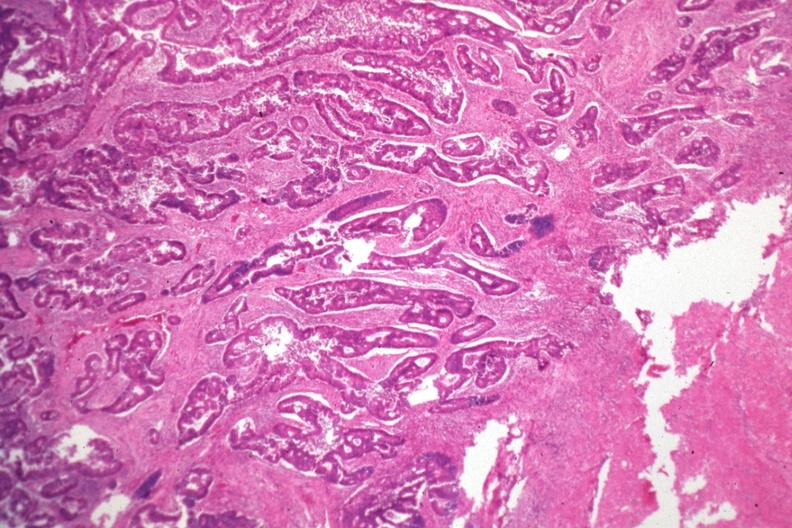s coronary artery anomalous origin left from pulmonary artery present?
Answer the question using a single word or phrase. No 